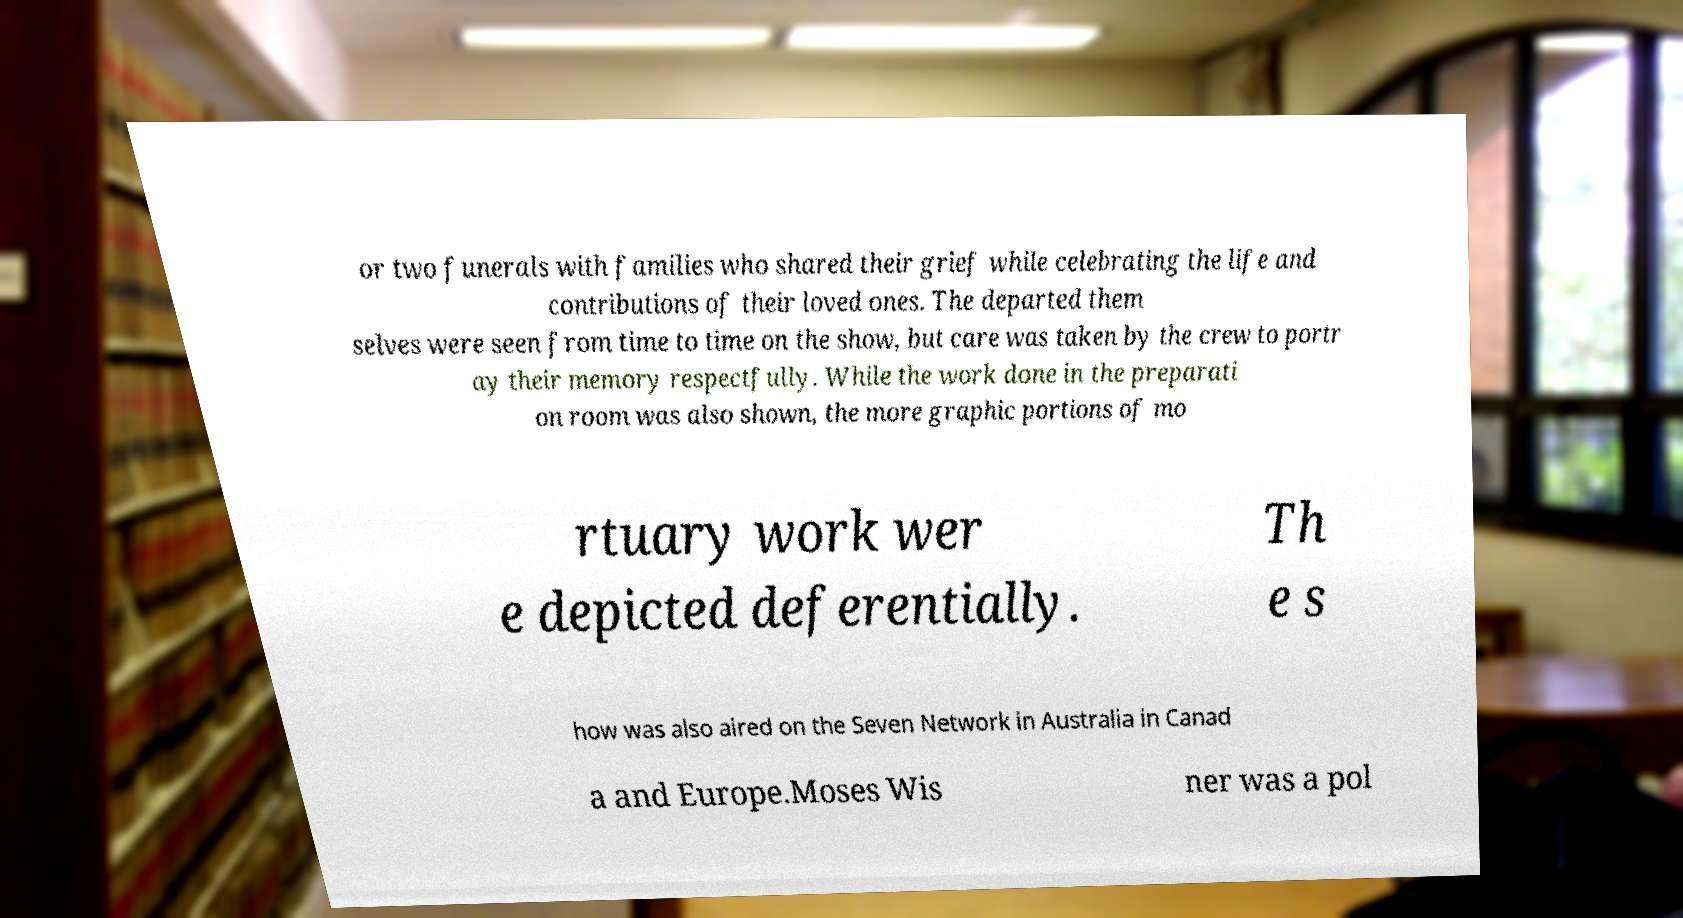There's text embedded in this image that I need extracted. Can you transcribe it verbatim? or two funerals with families who shared their grief while celebrating the life and contributions of their loved ones. The departed them selves were seen from time to time on the show, but care was taken by the crew to portr ay their memory respectfully. While the work done in the preparati on room was also shown, the more graphic portions of mo rtuary work wer e depicted deferentially. Th e s how was also aired on the Seven Network in Australia in Canad a and Europe.Moses Wis ner was a pol 